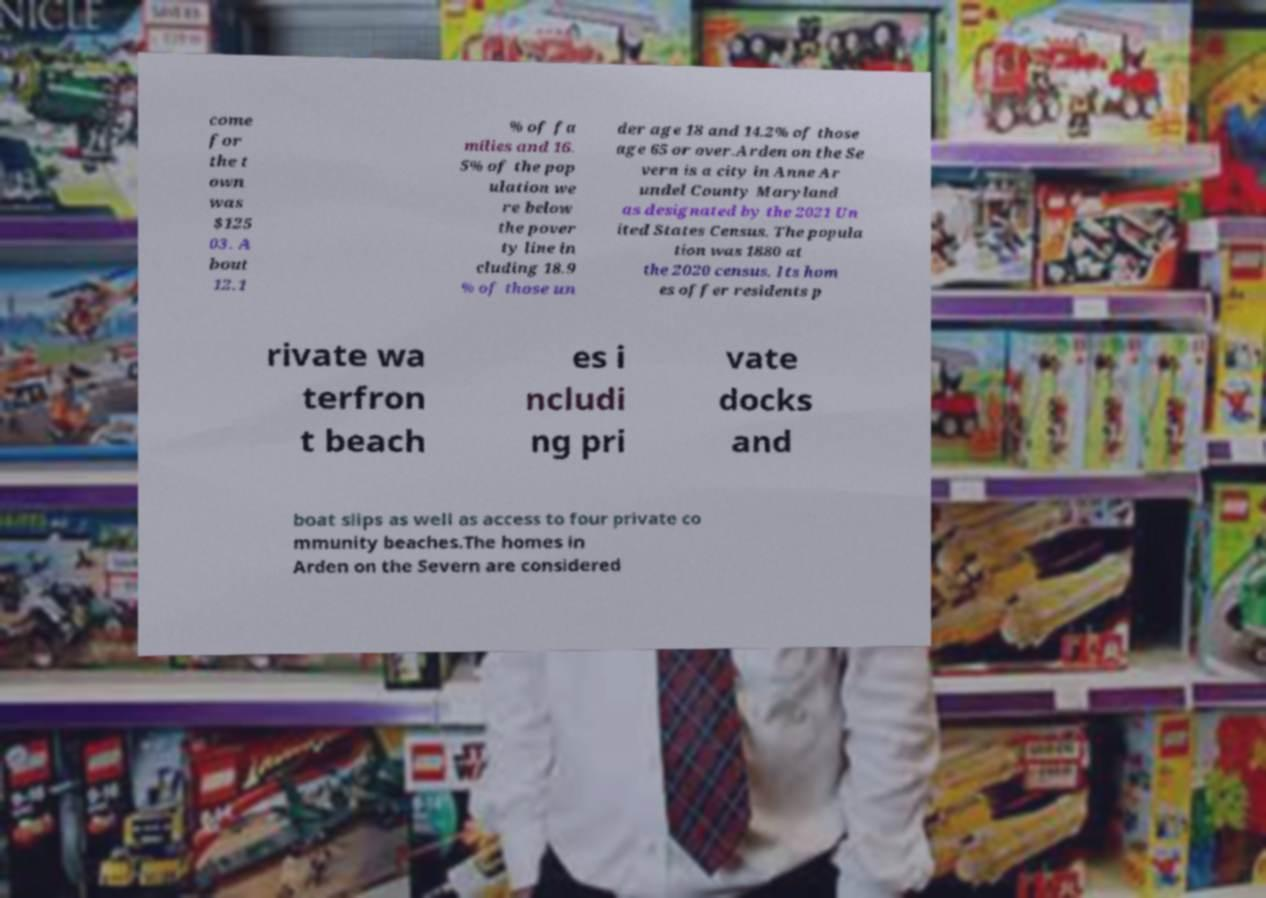What messages or text are displayed in this image? I need them in a readable, typed format. come for the t own was $125 03. A bout 12.1 % of fa milies and 16. 5% of the pop ulation we re below the pover ty line in cluding 18.9 % of those un der age 18 and 14.2% of those age 65 or over.Arden on the Se vern is a city in Anne Ar undel County Maryland as designated by the 2021 Un ited States Census. The popula tion was 1880 at the 2020 census. Its hom es offer residents p rivate wa terfron t beach es i ncludi ng pri vate docks and boat slips as well as access to four private co mmunity beaches.The homes in Arden on the Severn are considered 